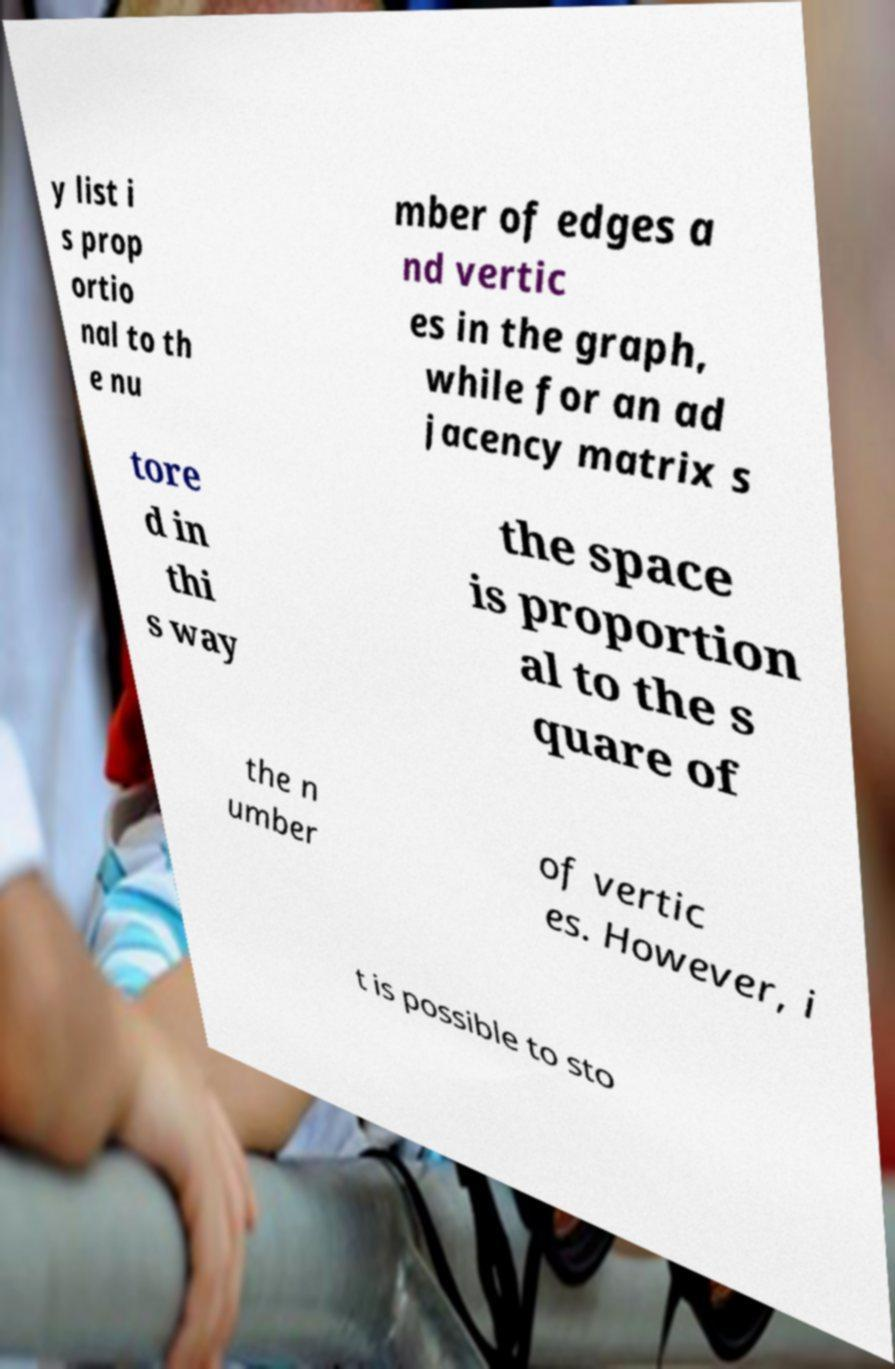I need the written content from this picture converted into text. Can you do that? y list i s prop ortio nal to th e nu mber of edges a nd vertic es in the graph, while for an ad jacency matrix s tore d in thi s way the space is proportion al to the s quare of the n umber of vertic es. However, i t is possible to sto 